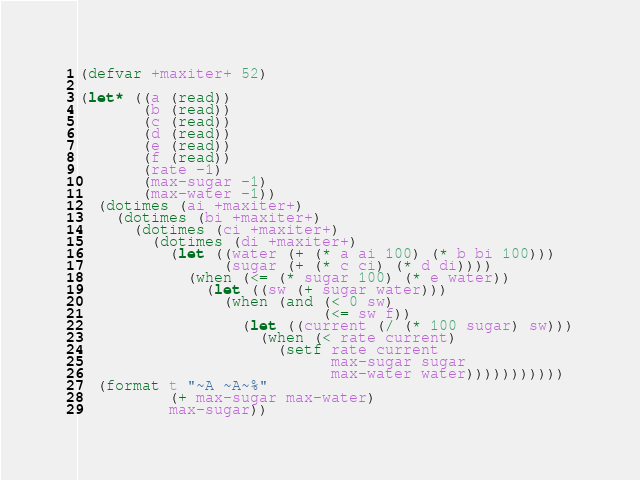<code> <loc_0><loc_0><loc_500><loc_500><_Lisp_>(defvar +maxiter+ 52)

(let* ((a (read))
       (b (read))
       (c (read))
       (d (read))
       (e (read))
       (f (read))
       (rate -1)
       (max-sugar -1)
       (max-water -1))
  (dotimes (ai +maxiter+)
    (dotimes (bi +maxiter+)
      (dotimes (ci +maxiter+)
        (dotimes (di +maxiter+)
          (let ((water (+ (* a ai 100) (* b bi 100)))
                (sugar (+ (* c ci) (* d di))))
            (when (<= (* sugar 100) (* e water))
              (let ((sw (+ sugar water)))
                (when (and (< 0 sw)
                           (<= sw f))
                  (let ((current (/ (* 100 sugar) sw)))
                    (when (< rate current)
                      (setf rate current
                            max-sugar sugar
                            max-water water)))))))))))
  (format t "~A ~A~%"
          (+ max-sugar max-water)
          max-sugar))
</code> 